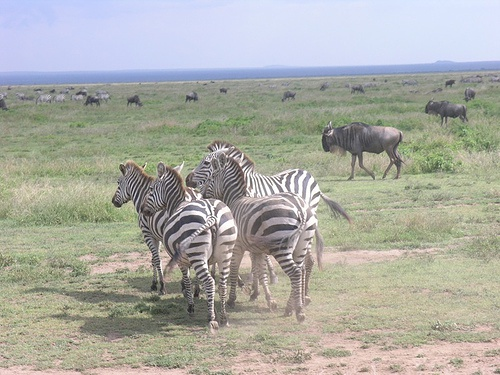Describe the objects in this image and their specific colors. I can see zebra in lavender, darkgray, gray, and lightgray tones, zebra in lavender, gray, darkgray, and lightgray tones, zebra in lavender, white, darkgray, and gray tones, and zebra in lavender, gray, darkgray, and black tones in this image. 